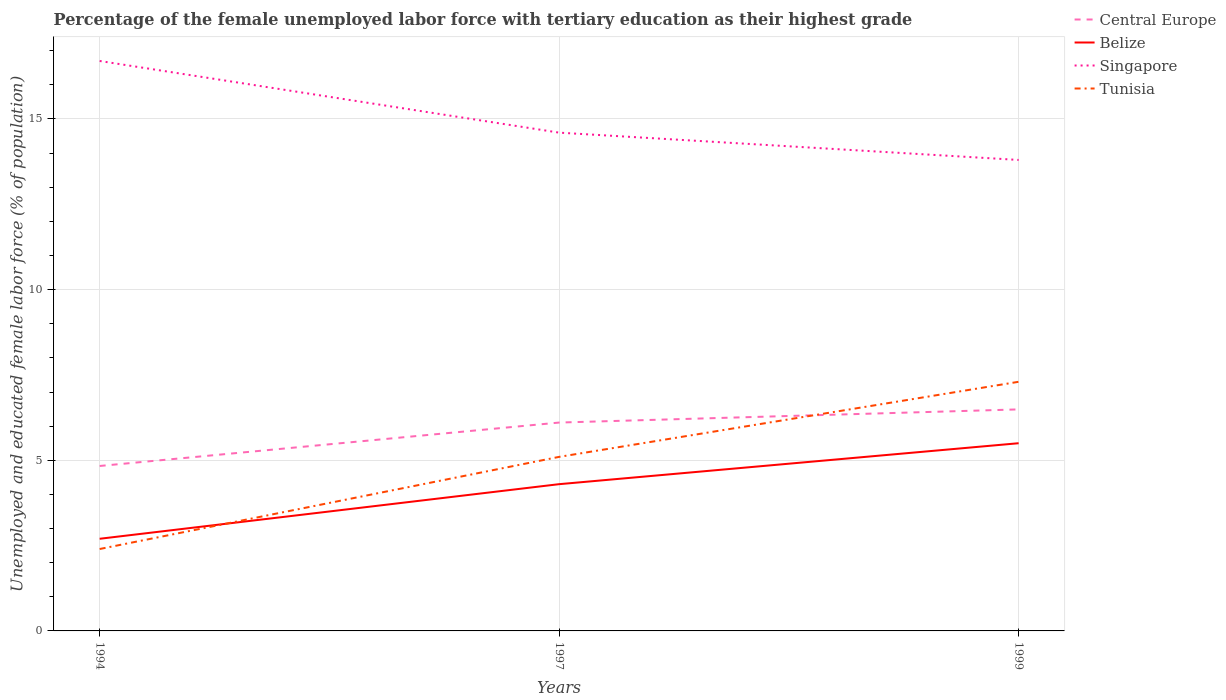How many different coloured lines are there?
Give a very brief answer. 4. Does the line corresponding to Belize intersect with the line corresponding to Central Europe?
Offer a terse response. No. Is the number of lines equal to the number of legend labels?
Offer a terse response. Yes. Across all years, what is the maximum percentage of the unemployed female labor force with tertiary education in Tunisia?
Ensure brevity in your answer.  2.4. What is the total percentage of the unemployed female labor force with tertiary education in Belize in the graph?
Provide a short and direct response. -1.2. What is the difference between the highest and the second highest percentage of the unemployed female labor force with tertiary education in Central Europe?
Your answer should be very brief. 1.66. Is the percentage of the unemployed female labor force with tertiary education in Tunisia strictly greater than the percentage of the unemployed female labor force with tertiary education in Belize over the years?
Ensure brevity in your answer.  No. How many lines are there?
Provide a succinct answer. 4. How many years are there in the graph?
Keep it short and to the point. 3. Are the values on the major ticks of Y-axis written in scientific E-notation?
Offer a very short reply. No. Does the graph contain any zero values?
Provide a succinct answer. No. How many legend labels are there?
Your answer should be compact. 4. How are the legend labels stacked?
Offer a terse response. Vertical. What is the title of the graph?
Make the answer very short. Percentage of the female unemployed labor force with tertiary education as their highest grade. Does "Suriname" appear as one of the legend labels in the graph?
Keep it short and to the point. No. What is the label or title of the X-axis?
Offer a very short reply. Years. What is the label or title of the Y-axis?
Offer a terse response. Unemployed and educated female labor force (% of population). What is the Unemployed and educated female labor force (% of population) in Central Europe in 1994?
Make the answer very short. 4.83. What is the Unemployed and educated female labor force (% of population) in Belize in 1994?
Your answer should be very brief. 2.7. What is the Unemployed and educated female labor force (% of population) in Singapore in 1994?
Your answer should be very brief. 16.7. What is the Unemployed and educated female labor force (% of population) in Tunisia in 1994?
Offer a terse response. 2.4. What is the Unemployed and educated female labor force (% of population) of Central Europe in 1997?
Offer a very short reply. 6.11. What is the Unemployed and educated female labor force (% of population) of Belize in 1997?
Your response must be concise. 4.3. What is the Unemployed and educated female labor force (% of population) in Singapore in 1997?
Your response must be concise. 14.6. What is the Unemployed and educated female labor force (% of population) in Tunisia in 1997?
Your answer should be compact. 5.1. What is the Unemployed and educated female labor force (% of population) of Central Europe in 1999?
Offer a very short reply. 6.49. What is the Unemployed and educated female labor force (% of population) in Belize in 1999?
Keep it short and to the point. 5.5. What is the Unemployed and educated female labor force (% of population) in Singapore in 1999?
Make the answer very short. 13.8. What is the Unemployed and educated female labor force (% of population) of Tunisia in 1999?
Provide a short and direct response. 7.3. Across all years, what is the maximum Unemployed and educated female labor force (% of population) in Central Europe?
Make the answer very short. 6.49. Across all years, what is the maximum Unemployed and educated female labor force (% of population) in Singapore?
Your answer should be compact. 16.7. Across all years, what is the maximum Unemployed and educated female labor force (% of population) of Tunisia?
Provide a short and direct response. 7.3. Across all years, what is the minimum Unemployed and educated female labor force (% of population) in Central Europe?
Your answer should be very brief. 4.83. Across all years, what is the minimum Unemployed and educated female labor force (% of population) in Belize?
Your answer should be compact. 2.7. Across all years, what is the minimum Unemployed and educated female labor force (% of population) in Singapore?
Your response must be concise. 13.8. Across all years, what is the minimum Unemployed and educated female labor force (% of population) of Tunisia?
Keep it short and to the point. 2.4. What is the total Unemployed and educated female labor force (% of population) in Central Europe in the graph?
Give a very brief answer. 17.43. What is the total Unemployed and educated female labor force (% of population) of Belize in the graph?
Offer a very short reply. 12.5. What is the total Unemployed and educated female labor force (% of population) in Singapore in the graph?
Provide a short and direct response. 45.1. What is the difference between the Unemployed and educated female labor force (% of population) of Central Europe in 1994 and that in 1997?
Provide a short and direct response. -1.27. What is the difference between the Unemployed and educated female labor force (% of population) in Belize in 1994 and that in 1997?
Your answer should be compact. -1.6. What is the difference between the Unemployed and educated female labor force (% of population) in Singapore in 1994 and that in 1997?
Provide a succinct answer. 2.1. What is the difference between the Unemployed and educated female labor force (% of population) in Central Europe in 1994 and that in 1999?
Your response must be concise. -1.66. What is the difference between the Unemployed and educated female labor force (% of population) of Central Europe in 1997 and that in 1999?
Offer a very short reply. -0.39. What is the difference between the Unemployed and educated female labor force (% of population) in Tunisia in 1997 and that in 1999?
Your response must be concise. -2.2. What is the difference between the Unemployed and educated female labor force (% of population) of Central Europe in 1994 and the Unemployed and educated female labor force (% of population) of Belize in 1997?
Provide a succinct answer. 0.53. What is the difference between the Unemployed and educated female labor force (% of population) in Central Europe in 1994 and the Unemployed and educated female labor force (% of population) in Singapore in 1997?
Provide a succinct answer. -9.77. What is the difference between the Unemployed and educated female labor force (% of population) in Central Europe in 1994 and the Unemployed and educated female labor force (% of population) in Tunisia in 1997?
Ensure brevity in your answer.  -0.27. What is the difference between the Unemployed and educated female labor force (% of population) in Belize in 1994 and the Unemployed and educated female labor force (% of population) in Singapore in 1997?
Keep it short and to the point. -11.9. What is the difference between the Unemployed and educated female labor force (% of population) in Central Europe in 1994 and the Unemployed and educated female labor force (% of population) in Belize in 1999?
Give a very brief answer. -0.67. What is the difference between the Unemployed and educated female labor force (% of population) in Central Europe in 1994 and the Unemployed and educated female labor force (% of population) in Singapore in 1999?
Make the answer very short. -8.97. What is the difference between the Unemployed and educated female labor force (% of population) in Central Europe in 1994 and the Unemployed and educated female labor force (% of population) in Tunisia in 1999?
Provide a succinct answer. -2.47. What is the difference between the Unemployed and educated female labor force (% of population) of Belize in 1994 and the Unemployed and educated female labor force (% of population) of Singapore in 1999?
Keep it short and to the point. -11.1. What is the difference between the Unemployed and educated female labor force (% of population) of Central Europe in 1997 and the Unemployed and educated female labor force (% of population) of Belize in 1999?
Make the answer very short. 0.61. What is the difference between the Unemployed and educated female labor force (% of population) of Central Europe in 1997 and the Unemployed and educated female labor force (% of population) of Singapore in 1999?
Your answer should be compact. -7.69. What is the difference between the Unemployed and educated female labor force (% of population) of Central Europe in 1997 and the Unemployed and educated female labor force (% of population) of Tunisia in 1999?
Provide a succinct answer. -1.19. What is the difference between the Unemployed and educated female labor force (% of population) of Belize in 1997 and the Unemployed and educated female labor force (% of population) of Tunisia in 1999?
Offer a very short reply. -3. What is the average Unemployed and educated female labor force (% of population) of Central Europe per year?
Offer a very short reply. 5.81. What is the average Unemployed and educated female labor force (% of population) of Belize per year?
Make the answer very short. 4.17. What is the average Unemployed and educated female labor force (% of population) of Singapore per year?
Keep it short and to the point. 15.03. What is the average Unemployed and educated female labor force (% of population) of Tunisia per year?
Offer a terse response. 4.93. In the year 1994, what is the difference between the Unemployed and educated female labor force (% of population) in Central Europe and Unemployed and educated female labor force (% of population) in Belize?
Give a very brief answer. 2.13. In the year 1994, what is the difference between the Unemployed and educated female labor force (% of population) in Central Europe and Unemployed and educated female labor force (% of population) in Singapore?
Your answer should be very brief. -11.87. In the year 1994, what is the difference between the Unemployed and educated female labor force (% of population) in Central Europe and Unemployed and educated female labor force (% of population) in Tunisia?
Your response must be concise. 2.43. In the year 1994, what is the difference between the Unemployed and educated female labor force (% of population) of Belize and Unemployed and educated female labor force (% of population) of Singapore?
Make the answer very short. -14. In the year 1997, what is the difference between the Unemployed and educated female labor force (% of population) in Central Europe and Unemployed and educated female labor force (% of population) in Belize?
Provide a succinct answer. 1.81. In the year 1997, what is the difference between the Unemployed and educated female labor force (% of population) in Central Europe and Unemployed and educated female labor force (% of population) in Singapore?
Your response must be concise. -8.49. In the year 1997, what is the difference between the Unemployed and educated female labor force (% of population) in Singapore and Unemployed and educated female labor force (% of population) in Tunisia?
Your answer should be compact. 9.5. In the year 1999, what is the difference between the Unemployed and educated female labor force (% of population) in Central Europe and Unemployed and educated female labor force (% of population) in Belize?
Your answer should be compact. 0.99. In the year 1999, what is the difference between the Unemployed and educated female labor force (% of population) of Central Europe and Unemployed and educated female labor force (% of population) of Singapore?
Make the answer very short. -7.31. In the year 1999, what is the difference between the Unemployed and educated female labor force (% of population) in Central Europe and Unemployed and educated female labor force (% of population) in Tunisia?
Keep it short and to the point. -0.81. In the year 1999, what is the difference between the Unemployed and educated female labor force (% of population) of Belize and Unemployed and educated female labor force (% of population) of Singapore?
Give a very brief answer. -8.3. What is the ratio of the Unemployed and educated female labor force (% of population) of Central Europe in 1994 to that in 1997?
Provide a succinct answer. 0.79. What is the ratio of the Unemployed and educated female labor force (% of population) in Belize in 1994 to that in 1997?
Your answer should be compact. 0.63. What is the ratio of the Unemployed and educated female labor force (% of population) of Singapore in 1994 to that in 1997?
Offer a very short reply. 1.14. What is the ratio of the Unemployed and educated female labor force (% of population) in Tunisia in 1994 to that in 1997?
Your response must be concise. 0.47. What is the ratio of the Unemployed and educated female labor force (% of population) of Central Europe in 1994 to that in 1999?
Provide a short and direct response. 0.74. What is the ratio of the Unemployed and educated female labor force (% of population) in Belize in 1994 to that in 1999?
Keep it short and to the point. 0.49. What is the ratio of the Unemployed and educated female labor force (% of population) in Singapore in 1994 to that in 1999?
Your answer should be compact. 1.21. What is the ratio of the Unemployed and educated female labor force (% of population) of Tunisia in 1994 to that in 1999?
Your answer should be very brief. 0.33. What is the ratio of the Unemployed and educated female labor force (% of population) in Central Europe in 1997 to that in 1999?
Your answer should be very brief. 0.94. What is the ratio of the Unemployed and educated female labor force (% of population) in Belize in 1997 to that in 1999?
Your answer should be compact. 0.78. What is the ratio of the Unemployed and educated female labor force (% of population) in Singapore in 1997 to that in 1999?
Keep it short and to the point. 1.06. What is the ratio of the Unemployed and educated female labor force (% of population) of Tunisia in 1997 to that in 1999?
Offer a terse response. 0.7. What is the difference between the highest and the second highest Unemployed and educated female labor force (% of population) in Central Europe?
Offer a very short reply. 0.39. What is the difference between the highest and the second highest Unemployed and educated female labor force (% of population) in Belize?
Provide a short and direct response. 1.2. What is the difference between the highest and the second highest Unemployed and educated female labor force (% of population) in Singapore?
Your answer should be very brief. 2.1. What is the difference between the highest and the lowest Unemployed and educated female labor force (% of population) in Central Europe?
Ensure brevity in your answer.  1.66. What is the difference between the highest and the lowest Unemployed and educated female labor force (% of population) in Belize?
Offer a very short reply. 2.8. What is the difference between the highest and the lowest Unemployed and educated female labor force (% of population) of Singapore?
Offer a very short reply. 2.9. What is the difference between the highest and the lowest Unemployed and educated female labor force (% of population) in Tunisia?
Give a very brief answer. 4.9. 